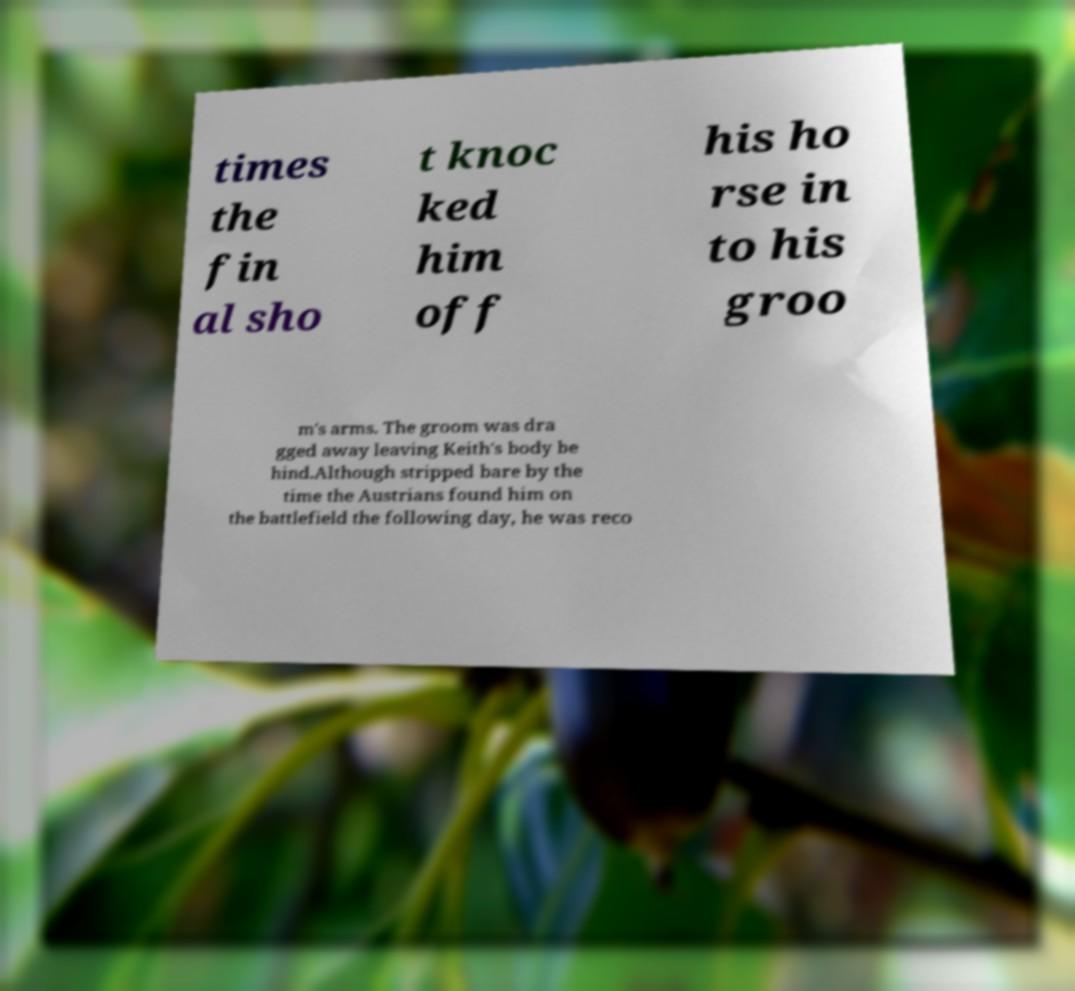Please read and relay the text visible in this image. What does it say? times the fin al sho t knoc ked him off his ho rse in to his groo m's arms. The groom was dra gged away leaving Keith's body be hind.Although stripped bare by the time the Austrians found him on the battlefield the following day, he was reco 